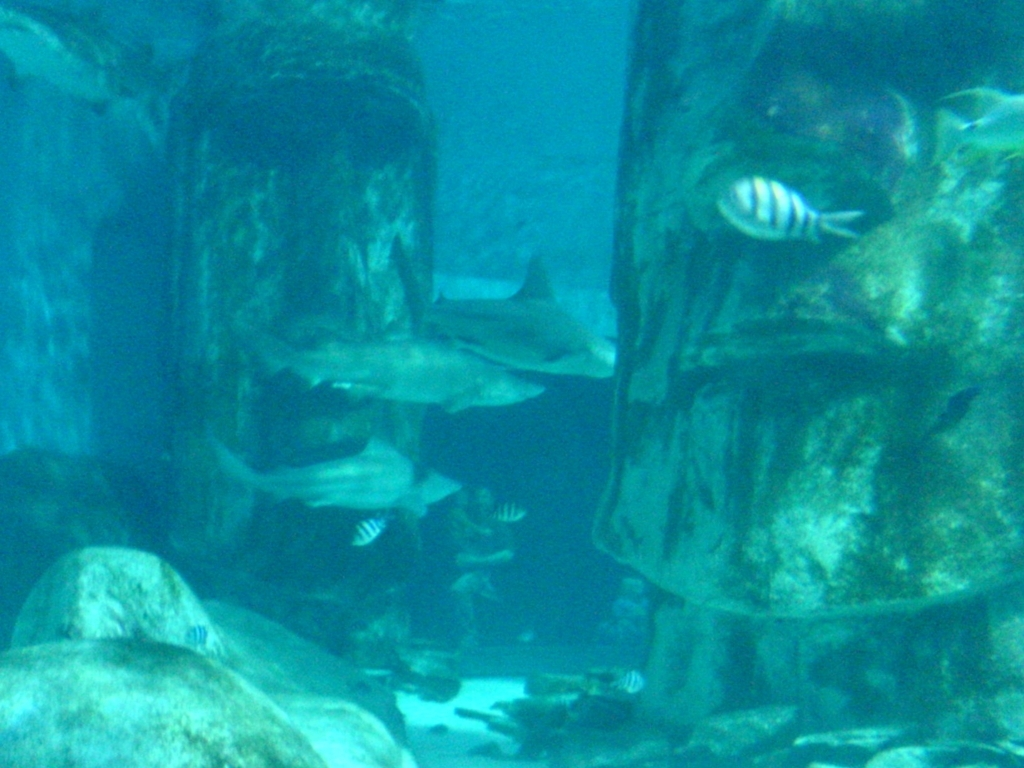What species of fish can be identified in this underwater image? The image shows a striped fish that resembles a sergeant major fish, easily recognized by its stripes and commonly found in such underwater environments. How does the blue tone of the water affect the perceived quality of the image? The blue tone, typical of underwater photography, can affect the perceived quality by creating a monochromatic hue that sometimes obscures fine details and can give an impression of blur or low resolution. 